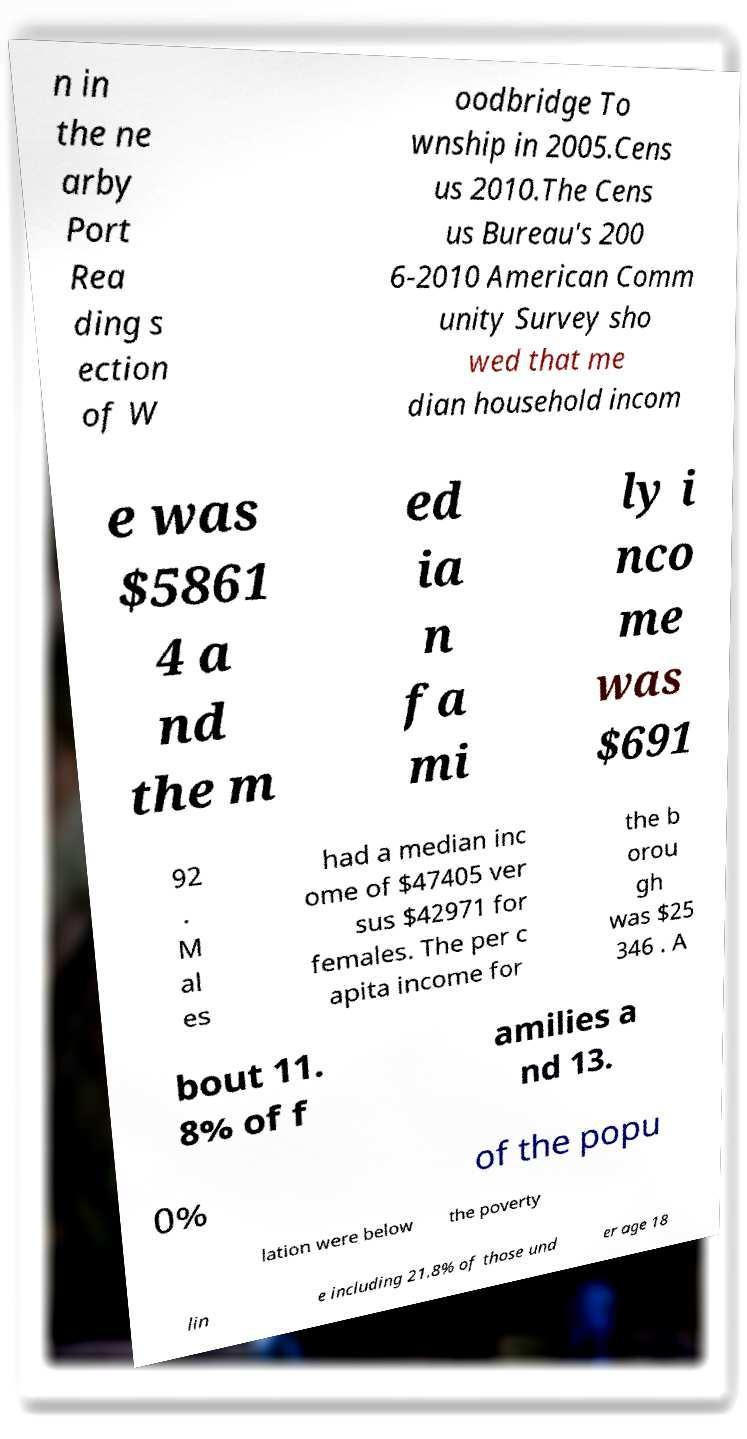What messages or text are displayed in this image? I need them in a readable, typed format. n in the ne arby Port Rea ding s ection of W oodbridge To wnship in 2005.Cens us 2010.The Cens us Bureau's 200 6-2010 American Comm unity Survey sho wed that me dian household incom e was $5861 4 a nd the m ed ia n fa mi ly i nco me was $691 92 . M al es had a median inc ome of $47405 ver sus $42971 for females. The per c apita income for the b orou gh was $25 346 . A bout 11. 8% of f amilies a nd 13. 0% of the popu lation were below the poverty lin e including 21.8% of those und er age 18 